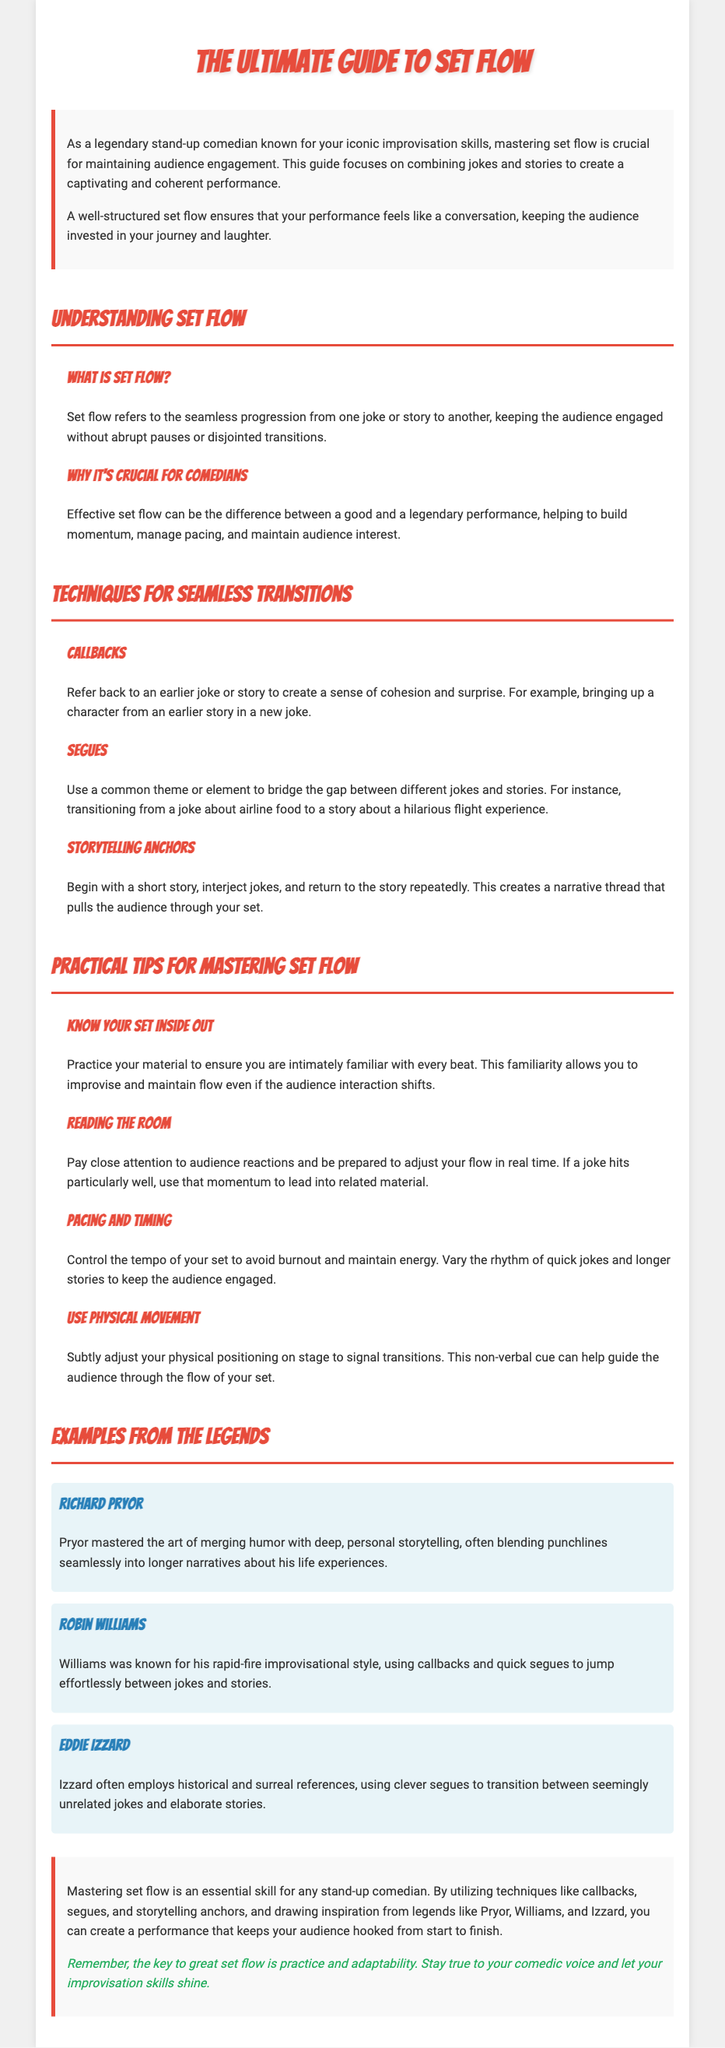What is the title of the guide? The title of the guide is present in the header of the document.
Answer: The Ultimate Guide to Set Flow Who is the intended audience for this guide? The intended audience for the guide is stated in the introductory paragraph.
Answer: stand-up comedians What technique involves referring back to an earlier joke? This technique is explained in the section about techniques for seamless transitions.
Answer: Callbacks What is one practical tip for mastering set flow? The section on practical tips lists suggestions for comedians.
Answer: Know Your Set Inside Out Name one legendary comedian mentioned in the examples. The document lists several renowned comedians in the examples section.
Answer: Richard Pryor What is the main purpose of mastering set flow? The purpose is discussed in the introduction and elsewhere in the document.
Answer: Maintaining audience engagement How does Robin Williams transition between jokes? This specific method is detailed in the examples from the legends.
Answer: Using callbacks and quick segues What should comedians do to read the audience? The guide offers advice on how to observe audience reactions.
Answer: Pay close attention to audience reactions 